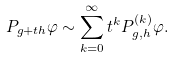Convert formula to latex. <formula><loc_0><loc_0><loc_500><loc_500>P _ { g + t h } \varphi \sim \sum _ { k = 0 } ^ { \infty } t ^ { k } P _ { g , h } ^ { \left ( k \right ) } \varphi .</formula> 